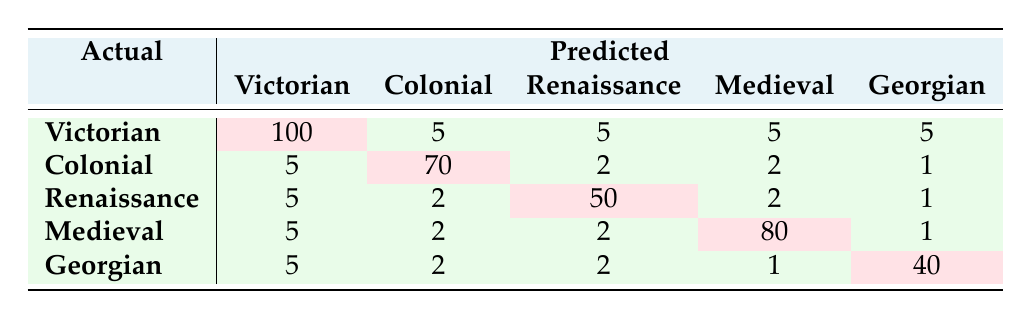What is the True Positive rate for the Victorian Era? True Positive rate is calculated as True Positives divided by the sum of True Positives and False Negatives. For the Victorian Era, True Positives is 100 and False Negatives is 20, so the rate is 100 / (100 + 20) = 100 / 120 = 0.8333 or 83.33%.
Answer: 83.33% How many visitors expected to attend tours of the Georgian Era? The table shows that 50 visitors expected to attend the Georgian Era tours. Therefore, the answer can be directly derived from the visitor preferences row.
Answer: 50 What is the total number of visitors who attended tours in the Medieval Era? From the confusion matrix, the total number of visitors who attended the Medieval Era is given by the True Positives (80) plus any False Positives, which includes the counts from other categories predicting Medieval Era. From the table in the row for Medieval, visitors actually attending was 80.
Answer: 80 How many false positives were there for the Colonial Era? The number of false positives for the Colonial Era is clearly indicated in the table as 10. This can be found directly in the specific row for the Colonial Era.
Answer: 10 Is it true that more visitors preferred the Renaissance over the Georgian Era? To answer this, we compare the visitor preferences: 60 for Renaissance and 50 for Georgian. Since 60 is greater than 50, the statement is true.
Answer: Yes What percentage of total visitors for the Medieval Era was correctly predicted as attending that tour? The percentage is calculated by taking True Positives (80) and dividing it by the total number of visitors who expressed interest (80 + 10 + 0 + 10 + 1 = 100). So, the percentage is (80 / 100) * 100 = 80%.
Answer: 80% What is the total number of False Negatives across all historical eras? To find the total number of False Negatives, we add the False Negatives for each era: 20 + 10 + 10 + 10 + 10 = 60.
Answer: 60 Which historical era had the highest number of False Positives? By inspecting the False Positive values in the table, the highest is observed in the Victorian Era, which has 20 False Positives. This is determined by comparing all the values in the False Positive category across the various eras.
Answer: Victorian Era What are the combined True Positive counts for the Renaissance and Georgian Eras? The combined count can be found by simply adding True Positives from both rows: Renaissance has 50 and Georgian has 40. Thus, the total is 50 + 40 = 90.
Answer: 90 